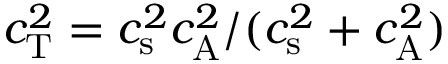<formula> <loc_0><loc_0><loc_500><loc_500>c _ { T } ^ { 2 } = { c _ { s } ^ { 2 } c _ { A } ^ { 2 } / ( c _ { s } ^ { 2 } + c _ { A } ^ { 2 } ) }</formula> 